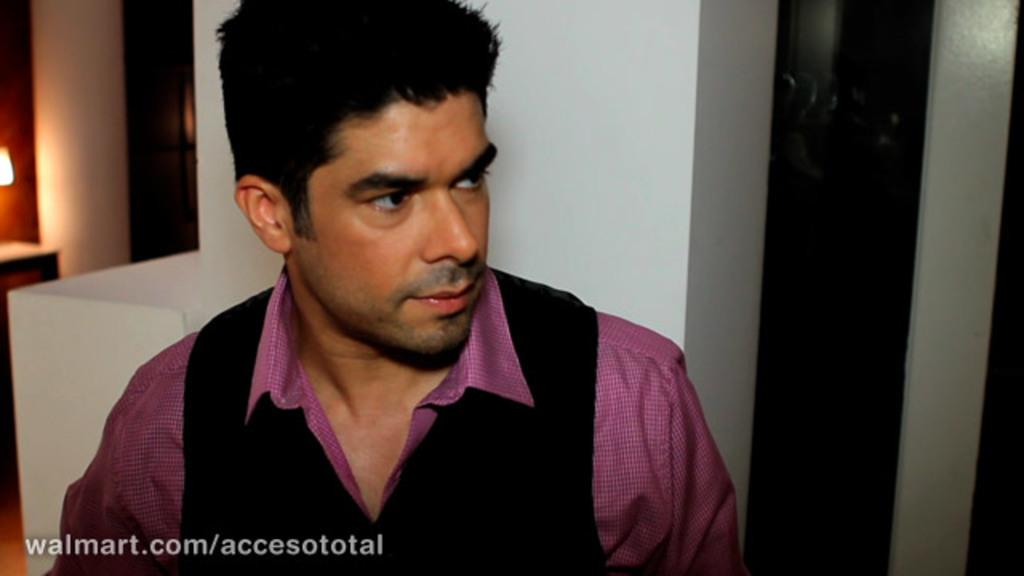Who is present in the image? There is a man in the image. What is the man wearing on his upper body? The man is wearing a purple shirt and a brown vest coat. Where is the man standing in the image? The man is standing in front of a wall. What can be seen on the left side of the wall? There is a light on the left side of the wall. What type of fruit is the man holding in the image? There is no fruit present in the image; the man is not holding any fruit. Is the man playing a musical instrument in the image? There is no indication in the image that the man is playing a musical instrument. 